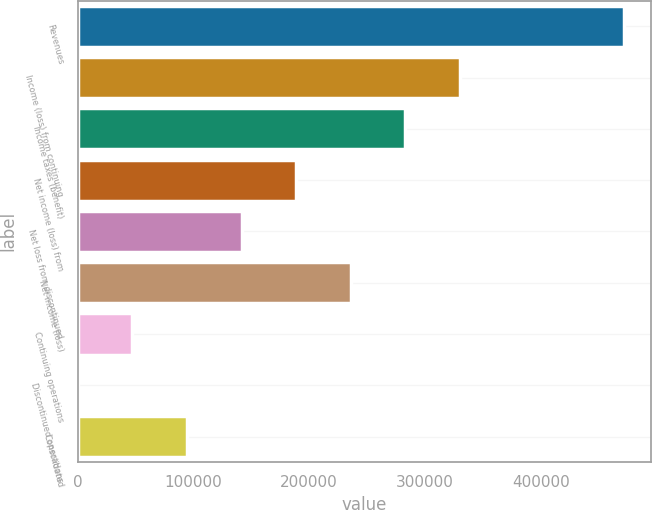<chart> <loc_0><loc_0><loc_500><loc_500><bar_chart><fcel>Revenues<fcel>Income (loss) from continuing<fcel>Income taxes (benefit)<fcel>Net income (loss) from<fcel>Net loss from discontinued<fcel>Net income (loss)<fcel>Continuing operations<fcel>Discontinued operations<fcel>Consolidated<nl><fcel>471979<fcel>330385<fcel>283187<fcel>188792<fcel>141594<fcel>235990<fcel>47197.9<fcel>0.01<fcel>94395.8<nl></chart> 